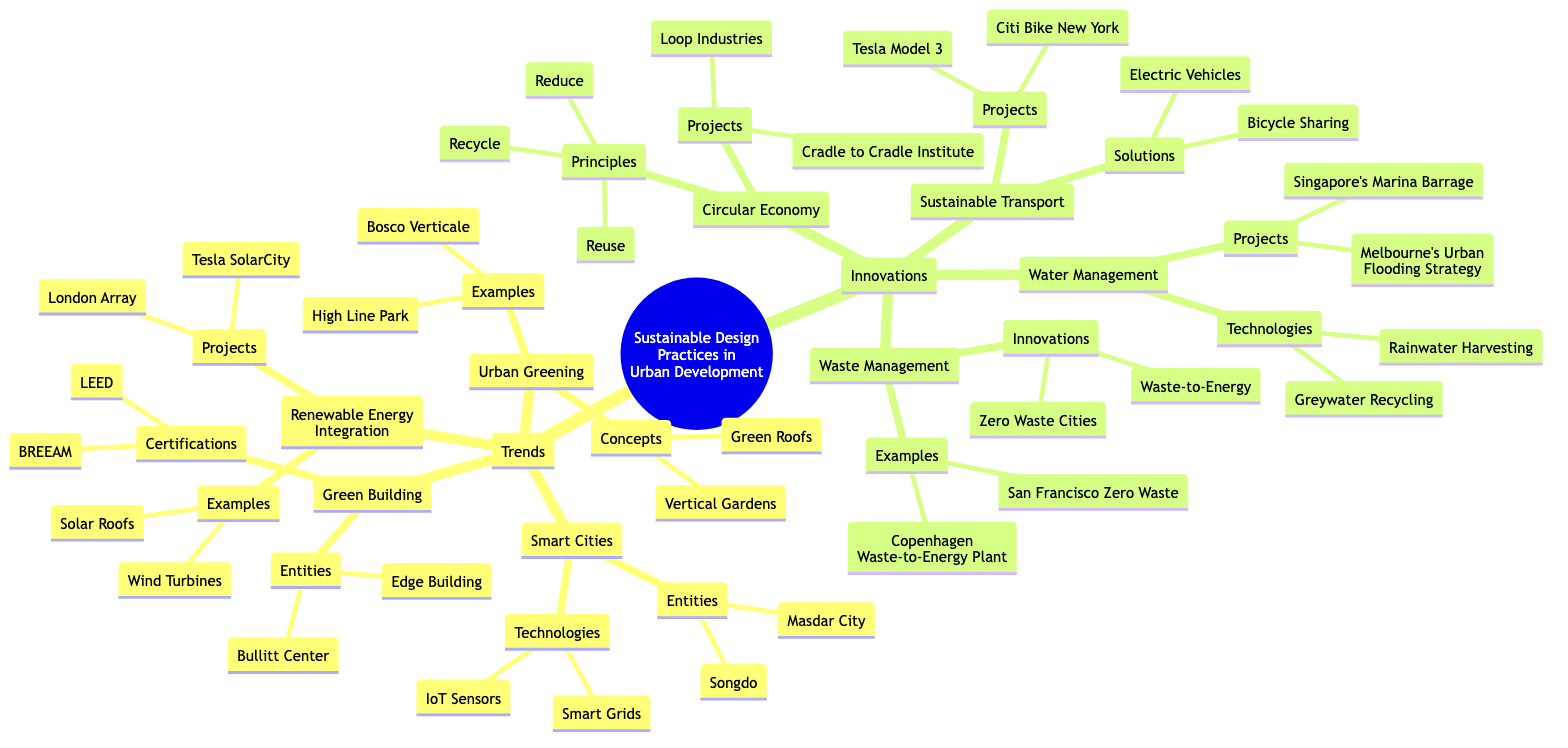What are the two entities listed under Smart Cities? By examining the "Smart Cities" section in the "Trends" category, we can see two entities identified: "Masdar City" and "Songdo."
Answer: Masdar City, Songdo Which certification is associated with Green Building? In the "Green Building" section, the certifications are explicitly mentioned, and "LEED" and "BREEAM" are listed there as associated certifications.
Answer: LEED, BREEAM What are the principles of the Circular Economy? In the "Circular Economy" section under "Innovations," the principles are outlined as "Reduce," "Reuse," and "Recycle," which indicates the foundational concepts of the approach.
Answer: Reduce, Reuse, Recycle Name one example of Urban Greening. Looking at the "Urban Greening" portion, we see examples listed under it, one of which is "Bosco Verticale," showing an instance of how urban areas are incorporating greenery.
Answer: Bosco Verticale How many projects are listed under Water Management? In the "Water Management" segment, there are two specific projects mentioned: "Singapore's Marina Barrage" and "Melbourne's Urban Flooding Strategy," thus accounting for a total of two projects.
Answer: 2 Which entity represents a renewable energy project? Within the "Renewable Energy Integration" category, two projects are mentioned: "Tesla SolarCity" and "London Array." Both represent examples of renewable energy initiatives.
Answer: Tesla SolarCity, London Array What technology is used in Sustainable Transport? Referring to the "Sustainable Transport" section, we see two solutions listed: "Electric Vehicles" and "Bicycle Sharing," illustrating technological advances in urban transportation.
Answer: Electric Vehicles, Bicycle Sharing Which city is associated with a Zero Waste initiative? In the "Waste Management" section, "San Francisco Zero Waste" is identified as an example of a city pursuing zero waste management strategies, highlighting its commitment to sustainability.
Answer: San Francisco Zero Waste How many concepts related to Urban Greening are mentioned? Under the "Urban Greening" category, there are two concepts listed, which are "Green Roofs" and "Vertical Gardens," resulting in a count of two concepts.
Answer: 2 